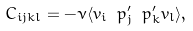Convert formula to latex. <formula><loc_0><loc_0><loc_500><loc_500>C _ { i j k l } = - \nu \langle v _ { i } \ p _ { j } ^ { \prime } \ p _ { k } ^ { \prime } v _ { l } \rangle ,</formula> 